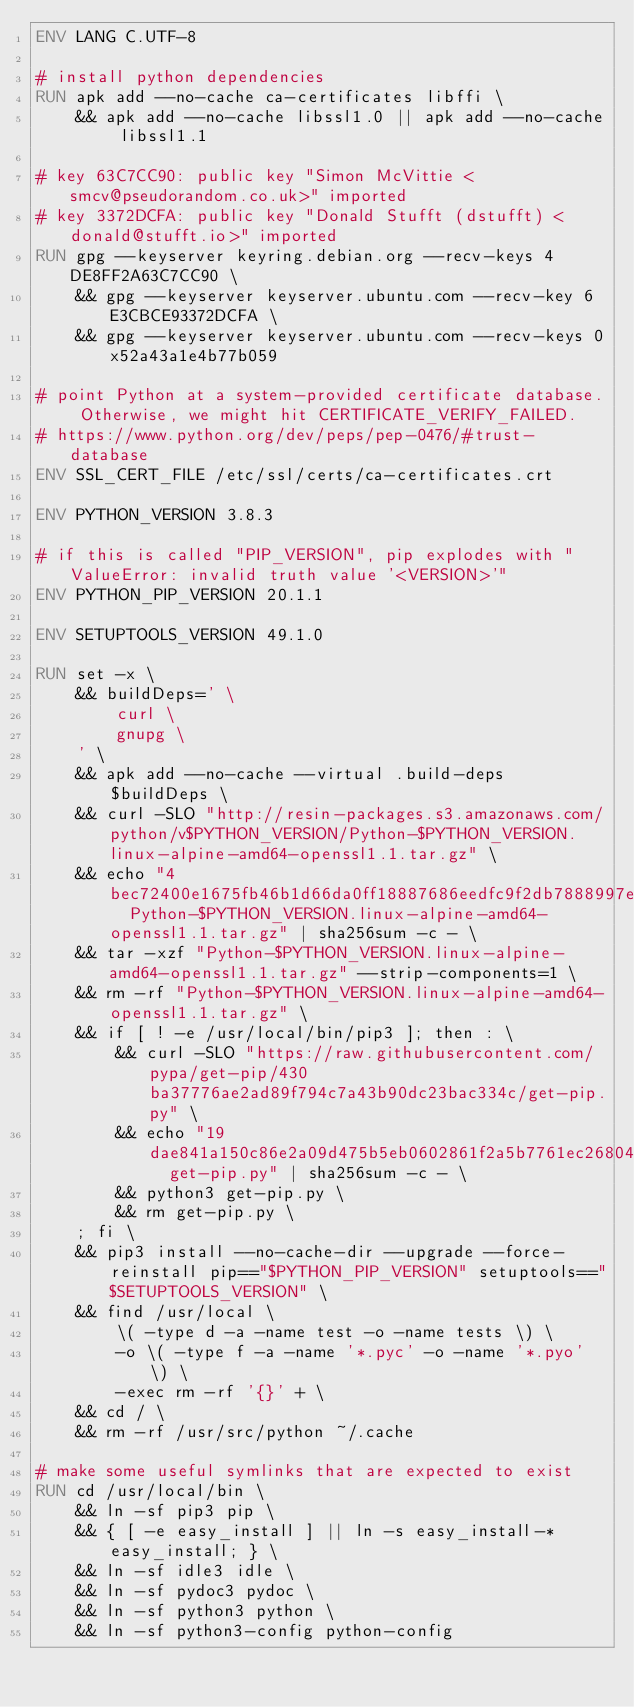<code> <loc_0><loc_0><loc_500><loc_500><_Dockerfile_>ENV LANG C.UTF-8

# install python dependencies
RUN apk add --no-cache ca-certificates libffi \
	&& apk add --no-cache libssl1.0 || apk add --no-cache libssl1.1

# key 63C7CC90: public key "Simon McVittie <smcv@pseudorandom.co.uk>" imported
# key 3372DCFA: public key "Donald Stufft (dstufft) <donald@stufft.io>" imported
RUN gpg --keyserver keyring.debian.org --recv-keys 4DE8FF2A63C7CC90 \
	&& gpg --keyserver keyserver.ubuntu.com --recv-key 6E3CBCE93372DCFA \
	&& gpg --keyserver keyserver.ubuntu.com --recv-keys 0x52a43a1e4b77b059

# point Python at a system-provided certificate database. Otherwise, we might hit CERTIFICATE_VERIFY_FAILED.
# https://www.python.org/dev/peps/pep-0476/#trust-database
ENV SSL_CERT_FILE /etc/ssl/certs/ca-certificates.crt

ENV PYTHON_VERSION 3.8.3

# if this is called "PIP_VERSION", pip explodes with "ValueError: invalid truth value '<VERSION>'"
ENV PYTHON_PIP_VERSION 20.1.1

ENV SETUPTOOLS_VERSION 49.1.0

RUN set -x \
	&& buildDeps=' \
		curl \
		gnupg \
	' \
	&& apk add --no-cache --virtual .build-deps $buildDeps \
	&& curl -SLO "http://resin-packages.s3.amazonaws.com/python/v$PYTHON_VERSION/Python-$PYTHON_VERSION.linux-alpine-amd64-openssl1.1.tar.gz" \
	&& echo "4bec72400e1675fb46b1d66da0ff18887686eedfc9f2db7888997e2806e4c087  Python-$PYTHON_VERSION.linux-alpine-amd64-openssl1.1.tar.gz" | sha256sum -c - \
	&& tar -xzf "Python-$PYTHON_VERSION.linux-alpine-amd64-openssl1.1.tar.gz" --strip-components=1 \
	&& rm -rf "Python-$PYTHON_VERSION.linux-alpine-amd64-openssl1.1.tar.gz" \
	&& if [ ! -e /usr/local/bin/pip3 ]; then : \
		&& curl -SLO "https://raw.githubusercontent.com/pypa/get-pip/430ba37776ae2ad89f794c7a43b90dc23bac334c/get-pip.py" \
		&& echo "19dae841a150c86e2a09d475b5eb0602861f2a5b7761ec268049a662dbd2bd0c  get-pip.py" | sha256sum -c - \
		&& python3 get-pip.py \
		&& rm get-pip.py \
	; fi \
	&& pip3 install --no-cache-dir --upgrade --force-reinstall pip=="$PYTHON_PIP_VERSION" setuptools=="$SETUPTOOLS_VERSION" \
	&& find /usr/local \
		\( -type d -a -name test -o -name tests \) \
		-o \( -type f -a -name '*.pyc' -o -name '*.pyo' \) \
		-exec rm -rf '{}' + \
	&& cd / \
	&& rm -rf /usr/src/python ~/.cache

# make some useful symlinks that are expected to exist
RUN cd /usr/local/bin \
	&& ln -sf pip3 pip \
	&& { [ -e easy_install ] || ln -s easy_install-* easy_install; } \
	&& ln -sf idle3 idle \
	&& ln -sf pydoc3 pydoc \
	&& ln -sf python3 python \
	&& ln -sf python3-config python-config
</code> 